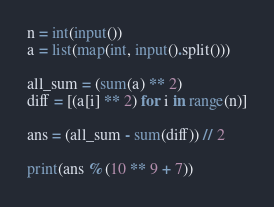Convert code to text. <code><loc_0><loc_0><loc_500><loc_500><_Python_>n = int(input())
a = list(map(int, input().split()))

all_sum = (sum(a) ** 2)
diff = [(a[i] ** 2) for i in range(n)]

ans = (all_sum - sum(diff)) // 2

print(ans % (10 ** 9 + 7))</code> 